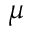<formula> <loc_0><loc_0><loc_500><loc_500>\mu</formula> 